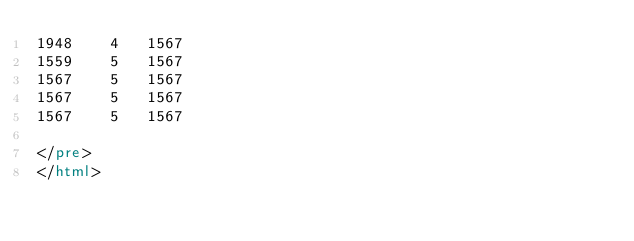<code> <loc_0><loc_0><loc_500><loc_500><_HTML_>1948	4	1567
1559	5	1567
1567	5	1567
1567	5	1567
1567	5	1567

</pre>
</html>
</code> 